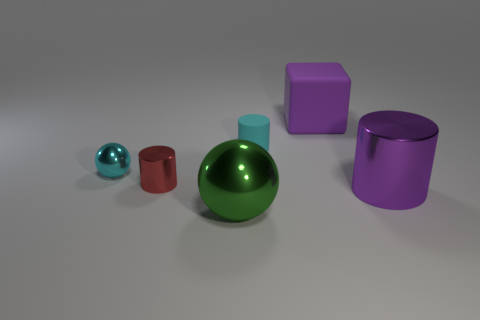Add 3 tiny yellow blocks. How many objects exist? 9 Subtract all blocks. How many objects are left? 5 Add 4 small cyan spheres. How many small cyan spheres are left? 5 Add 5 rubber objects. How many rubber objects exist? 7 Subtract 0 gray spheres. How many objects are left? 6 Subtract all large red metallic things. Subtract all shiny objects. How many objects are left? 2 